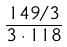Convert formula to latex. <formula><loc_0><loc_0><loc_500><loc_500>\frac { 1 4 9 / 3 } { 3 \cdot 1 1 8 }</formula> 